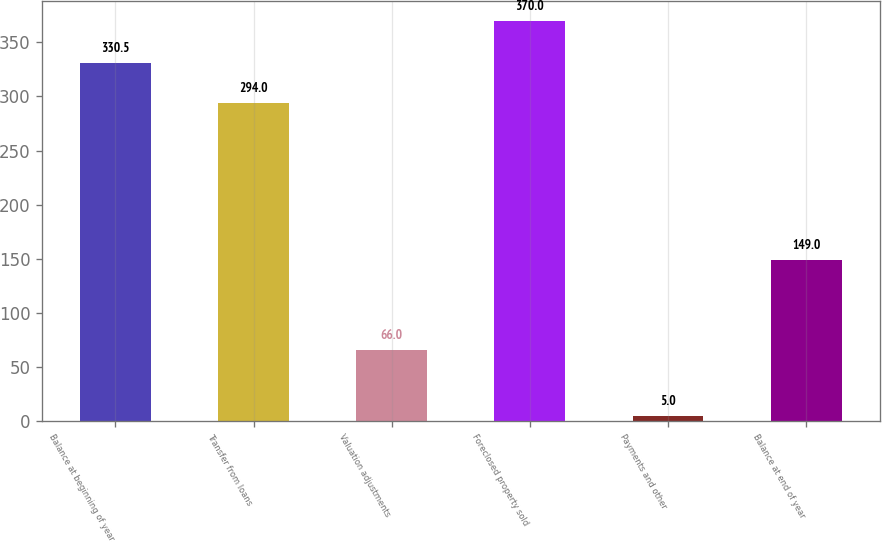Convert chart. <chart><loc_0><loc_0><loc_500><loc_500><bar_chart><fcel>Balance at beginning of year<fcel>Transfer from loans<fcel>Valuation adjustments<fcel>Foreclosed property sold<fcel>Payments and other<fcel>Balance at end of year<nl><fcel>330.5<fcel>294<fcel>66<fcel>370<fcel>5<fcel>149<nl></chart> 